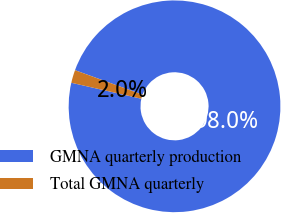<chart> <loc_0><loc_0><loc_500><loc_500><pie_chart><fcel>GMNA quarterly production<fcel>Total GMNA quarterly<nl><fcel>98.03%<fcel>1.97%<nl></chart> 